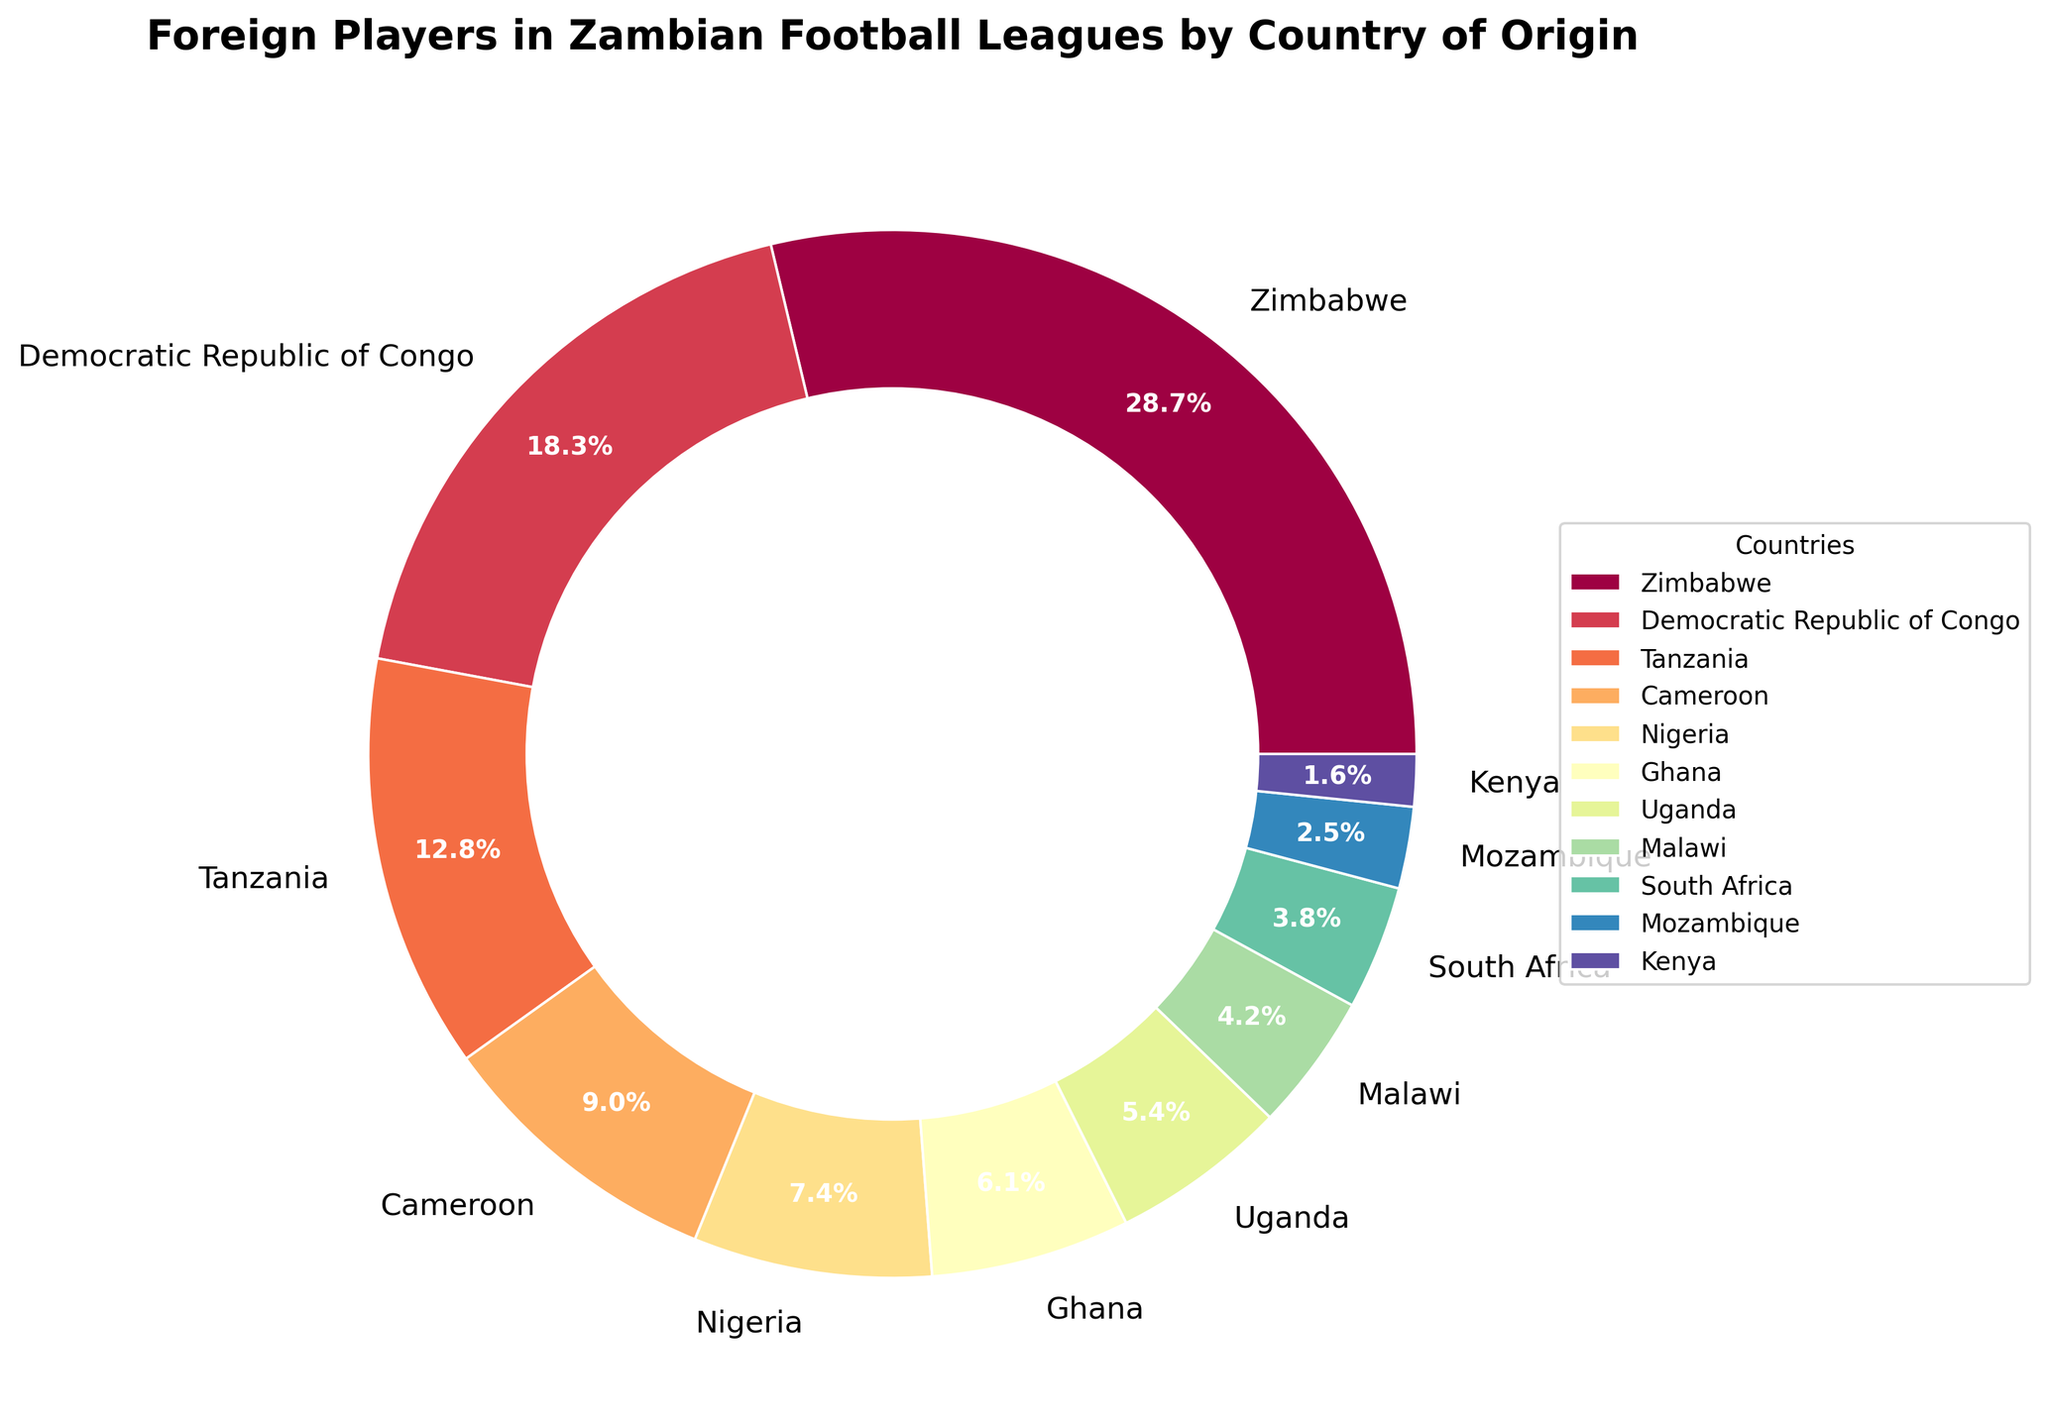Which country has the highest percentage of foreign players in Zambian football leagues? The country with the largest portion of the pie chart corresponds to Zimbabwe.
Answer: Zimbabwe Which countries have a percentage of foreign players higher than 10%? Looking at the wedges bigger than 10% on the pie chart, we see Zimbabwe, Democratic Republic of Congo, and Tanzania.
Answer: Zimbabwe, Democratic Republic of Congo, Tanzania What is the combined percentage of foreign players from Zimbabwe and Tanzania? Sum the percentages of Zimbabwe (28.5%) and Tanzania (12.7%) to get 28.5 + 12.7 = 41.2%.
Answer: 41.2% Which country has a smaller percentage of foreign players: Nigeria or Ghana? Compare the sizes of Nigeria's and Ghana's wedges on the pie chart; Nigeria has 7.3% and Ghana has 6.1%.
Answer: Ghana Are there more foreign players from Cameroon or South Africa in Zambian football leagues? Check and compare the pie slices for Cameroon (8.9%) and South Africa (3.8%).
Answer: Cameroon What is the total percentage of foreign players from countries with less than 5% representation? Add the percentages of countries with less than 5%, which are Uganda (5.4%), Malawi (4.2%), South Africa (3.8%), Mozambique (2.5%), Kenya (1.6%), and others below 1%. The total is 0.8 (Senegal) + 0.5 (Ivory Coast) + 0.3 (Namibia) + 0.2 (Burundi) = 1.8%. Thus, 1.8 + 4.2 + 3.8 + 2.5 + 1.6 = 13.9%.
Answer: 13.9% What is the visual difference between the wedge for Cameroon and Democratic Republic of Congo? The wedge for Democratic Republic of Congo is larger than that of Cameroon, with 18.2% vs. 8.9%, indicating that the Democratic Republic of Congo has more foreign players in Zambian leagues.
Answer: Democratic Republic of Congo is larger By what percentage does the representation of foreign players from Zimbabwe exceed that of Nigeria? Subtract the percentage of Nigeria (7.3%) from Zimbabwe (28.5%), so 28.5 - 7.3 = 21.2%.
Answer: 21.2% If players from Tanzania and Malawi are combined as a single category, would their total percentage surpass that of the Democratic Republic of Congo? Add the percentages of Tanzania (12.7%) and Malawi (4.2%) to get 12.7 + 4.2 = 16.9%. Compare this to Democratic Republic of Congo's 18.2%. 16.9% does not surpass 18.2%.
Answer: No What color coding is used for the countries with the top three highest percentages of foreign players? The colors for Zimbabwe, Democratic Republic of Congo, and Tanzania vary, corresponding to their positions on the color gradient of the pie chart, which is usually done with visually distinct colors. The exact shades can be seen directly on the chart.
Answer: Three distinct colors (exact shades visible on chart) 